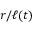<formula> <loc_0><loc_0><loc_500><loc_500>r / \ell ( t )</formula> 